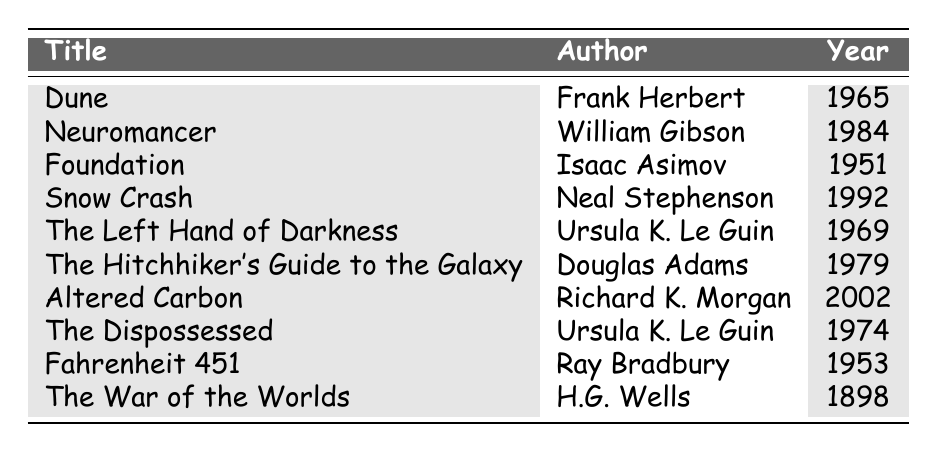What is the publication year of "Neuromancer"? The table lists "Neuromancer" by William Gibson, and the corresponding publication year shown is 1984.
Answer: 1984 Which author wrote "Foundation"? By looking at the table, "Foundation" is listed under the author Isaac Asimov.
Answer: Isaac Asimov How many books were published in the 1970s? The table shows "The Left Hand of Darkness" (1969), "The Hitchhiker's Guide to the Galaxy" (1979), "The Dispossessed" (1974). There are two books, "The Hitchhiker's Guide to the Galaxy" and "The Dispossessed," that belong to the 1970s, making it a total of 3.
Answer: 3 What is the difference between the publication year of "Dune" and "Fahrenheit 451"? "Dune" was published in 1965, and "Fahrenheit 451" in 1953. When calculating the difference: 1965 - 1953 = 12.
Answer: 12 Was "The War of the Worlds" published before "Snow Crash"? "The War of the Worlds" was published in 1898, and "Snow Crash" was published in 1992. Since 1898 is earlier than 1992, it is true that "The War of the Worlds" was published first.
Answer: Yes What is the average publication year of all the books listed in the table? To find the average, first, sum the years: (1965 + 1984 + 1951 + 1992 + 1969 + 1979 + 2002 + 1974 + 1953 + 1898) = 19700. Then divide by the number of books (10): 19700 / 10 = 1970.
Answer: 1970 Which author has the most works listed in this table? Upon examining the table, Ursula K. Le Guin appears multiple times (for "The Left Hand of Darkness" and "The Dispossessed"), while other authors are listed only once. Thus, Ursula K. Le Guin has the most works.
Answer: Ursula K. Le Guin How many years separate "The Dispossessed" and "Altered Carbon"? "The Dispossessed" was published in 1974 and "Altered Carbon" in 2002. Calculating the difference: 2002 - 1974 = 28 years.
Answer: 28 years What is the earliest publication year among the listed books? Scanning the table, "The War of the Worlds" is listed at the year 1898, which is the earliest compared to all other entries.
Answer: 1898 Which book was published in the same decade as "Fahrenheit 451"? "Fahrenheit 451" is from the 1950s. Looking at the table, "Foundation" (1951) and "Dune" (1965) belong to the same decade—the 1950s. Thus, "Foundation" is published in the 1950s.
Answer: Foundation 